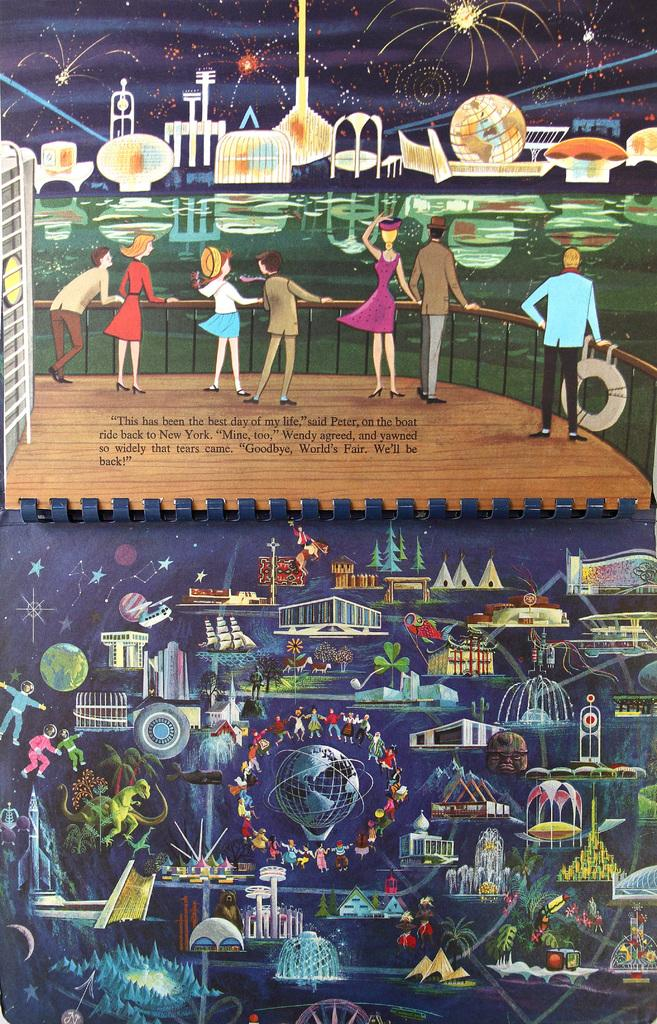<image>
Share a concise interpretation of the image provided. An illustration shows people standing on a boat with Peter exclaiming that the day was the best one on the boat. 